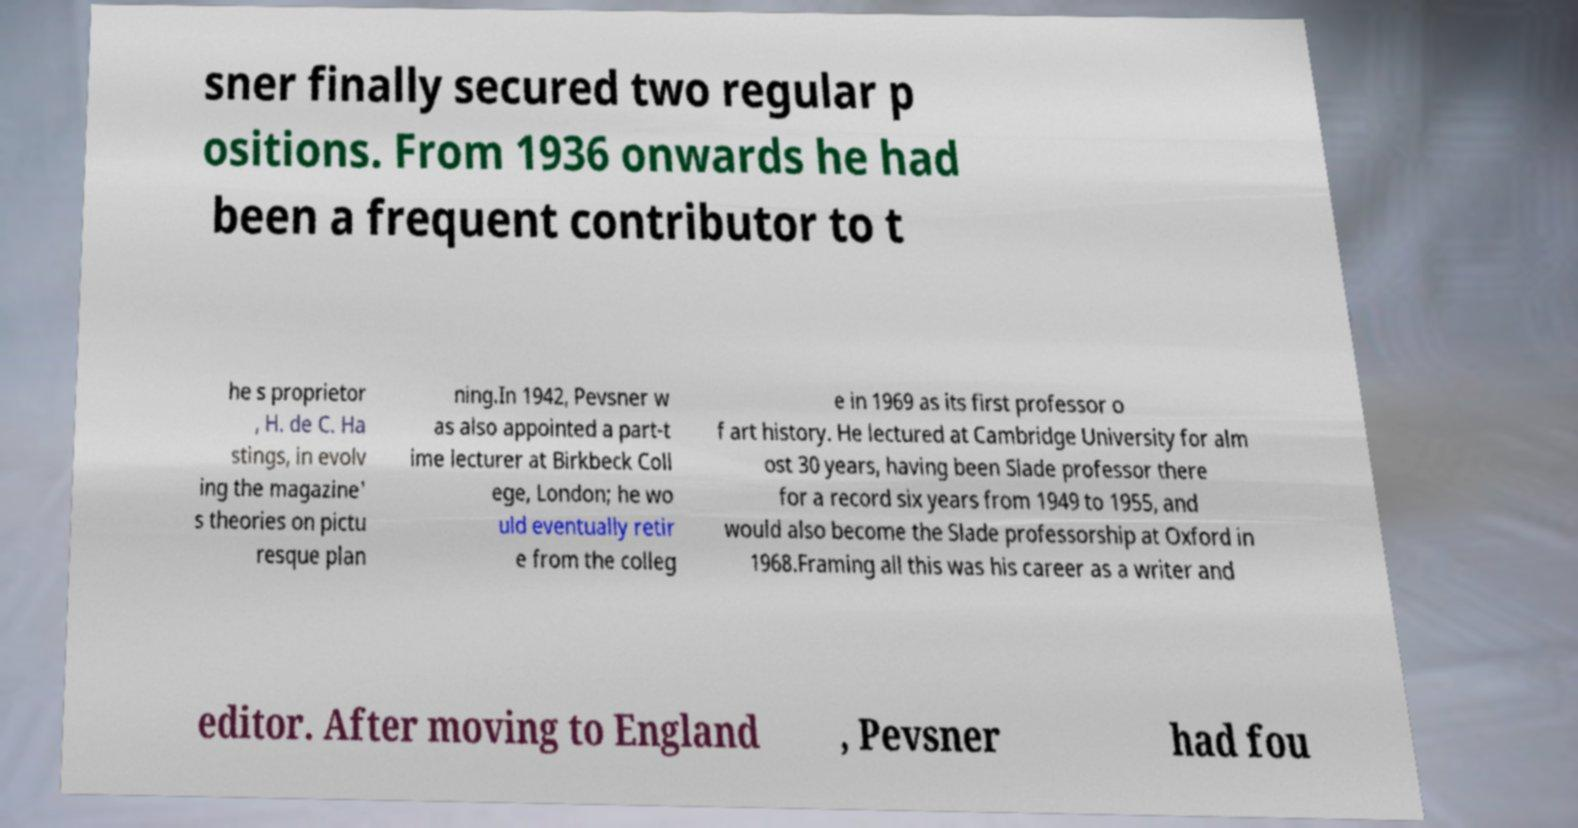There's text embedded in this image that I need extracted. Can you transcribe it verbatim? sner finally secured two regular p ositions. From 1936 onwards he had been a frequent contributor to t he s proprietor , H. de C. Ha stings, in evolv ing the magazine' s theories on pictu resque plan ning.In 1942, Pevsner w as also appointed a part-t ime lecturer at Birkbeck Coll ege, London; he wo uld eventually retir e from the colleg e in 1969 as its first professor o f art history. He lectured at Cambridge University for alm ost 30 years, having been Slade professor there for a record six years from 1949 to 1955, and would also become the Slade professorship at Oxford in 1968.Framing all this was his career as a writer and editor. After moving to England , Pevsner had fou 